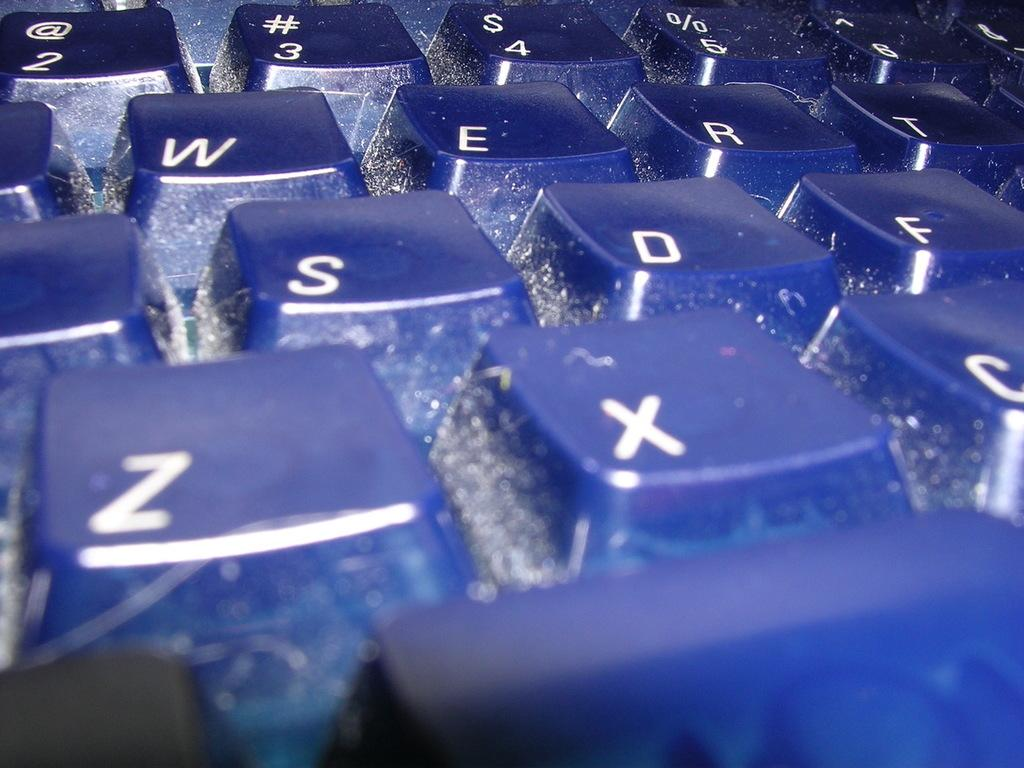<image>
Present a compact description of the photo's key features. A close up of blue keys including the Z and X keys. 